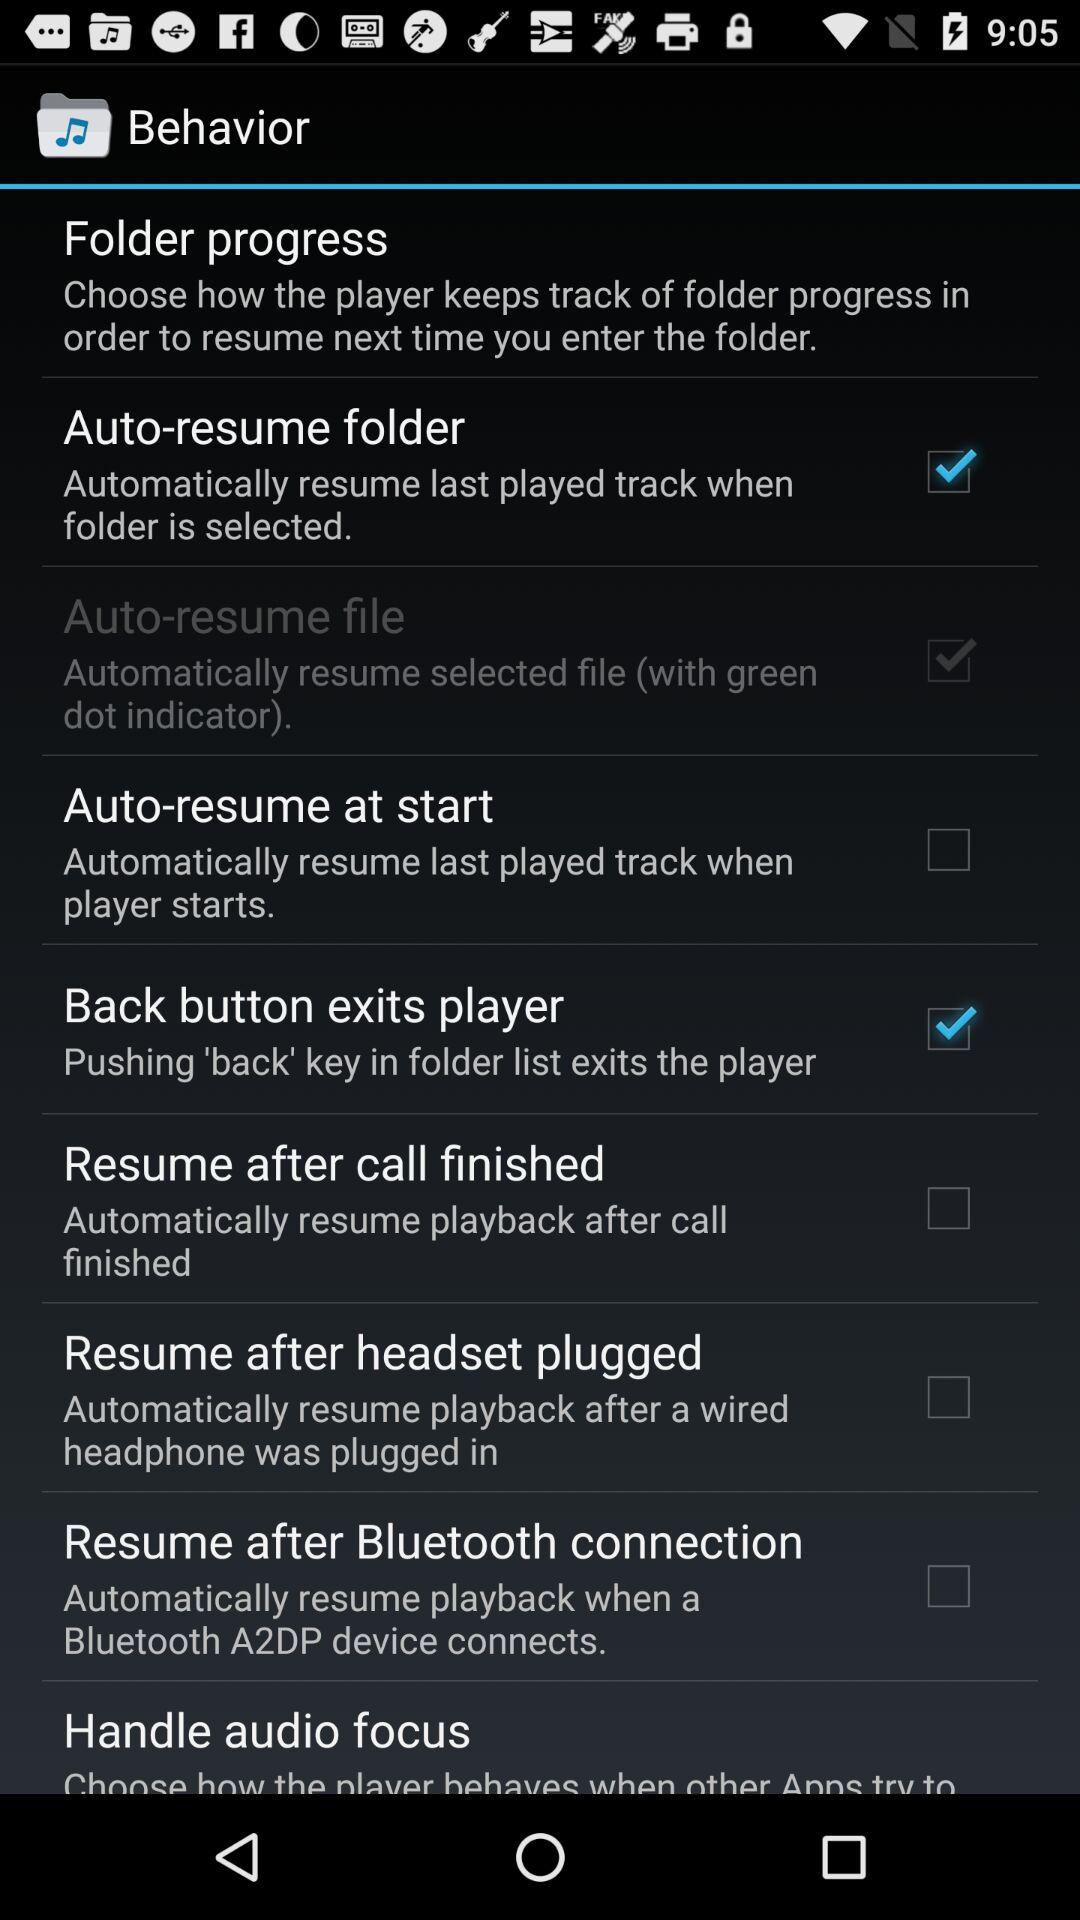Which options are checked? The checked options are "Auto-resume folder", "Auto-resume file" and "Back button exits player". 